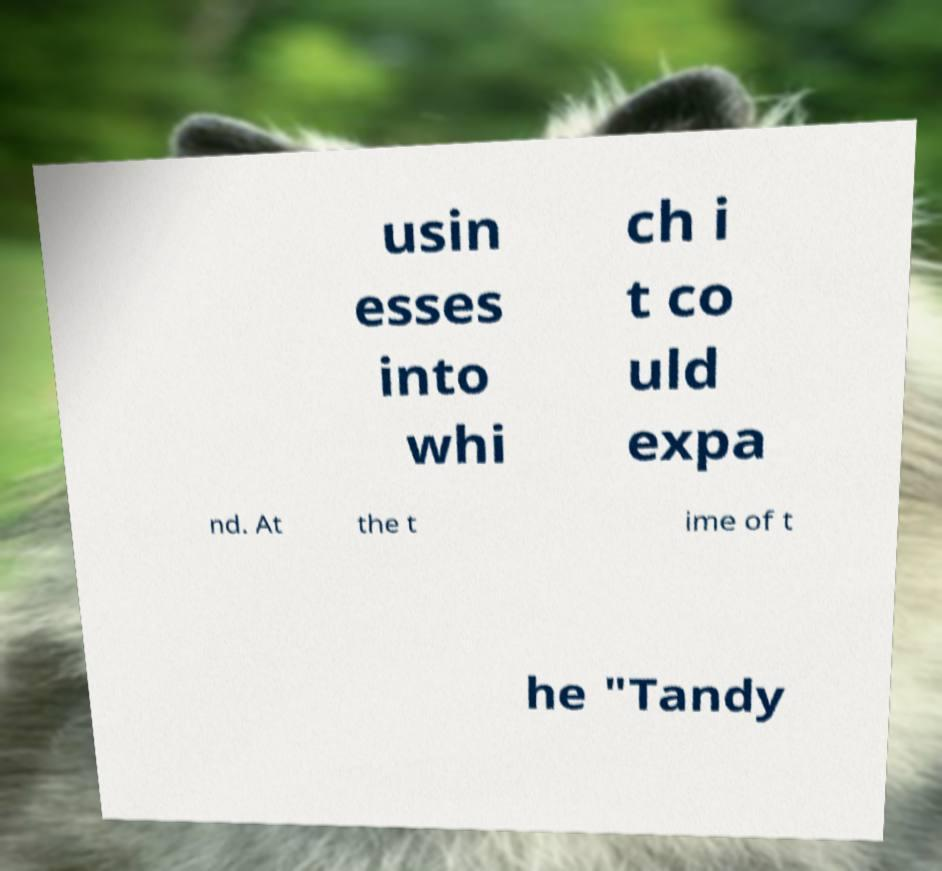I need the written content from this picture converted into text. Can you do that? usin esses into whi ch i t co uld expa nd. At the t ime of t he "Tandy 